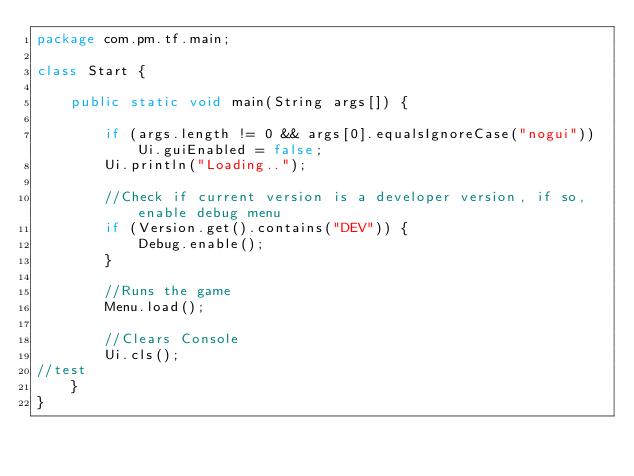<code> <loc_0><loc_0><loc_500><loc_500><_Java_>package com.pm.tf.main;

class Start {

    public static void main(String args[]) {

        if (args.length != 0 && args[0].equalsIgnoreCase("nogui")) Ui.guiEnabled = false;
        Ui.println("Loading..");

        //Check if current version is a developer version, if so, enable debug menu
        if (Version.get().contains("DEV")) {
            Debug.enable();
        }

        //Runs the game
        Menu.load();

        //Clears Console
        Ui.cls();
//test
    }
}

</code> 